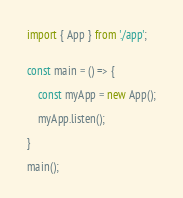Convert code to text. <code><loc_0><loc_0><loc_500><loc_500><_TypeScript_>import { App } from './app';


const main = () => {

    const myApp = new App();
    
    myApp.listen();
    
}

main();</code> 